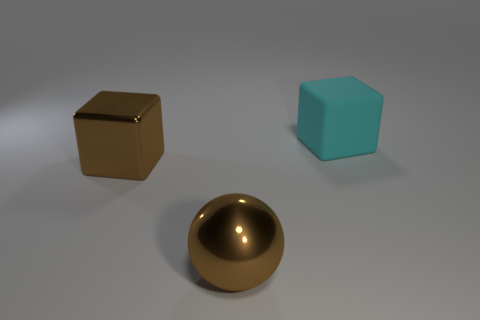Are there more brown balls that are behind the brown shiny cube than small brown cylinders?
Ensure brevity in your answer.  No. The brown sphere that is the same material as the big brown block is what size?
Provide a succinct answer. Large. Are there any big brown metal cubes in front of the sphere?
Provide a succinct answer. No. There is a block in front of the rubber block to the right of the large block that is to the left of the big cyan object; what size is it?
Give a very brief answer. Large. What is the big brown ball made of?
Provide a succinct answer. Metal. What is the size of the metallic thing that is the same color as the large ball?
Provide a succinct answer. Large. Do the rubber thing and the big brown object behind the brown ball have the same shape?
Provide a succinct answer. Yes. The block that is in front of the cube that is on the right side of the cube that is on the left side of the cyan object is made of what material?
Your response must be concise. Metal. How many purple metallic balls are there?
Offer a terse response. 0. How many gray things are either metallic spheres or tiny rubber balls?
Give a very brief answer. 0. 